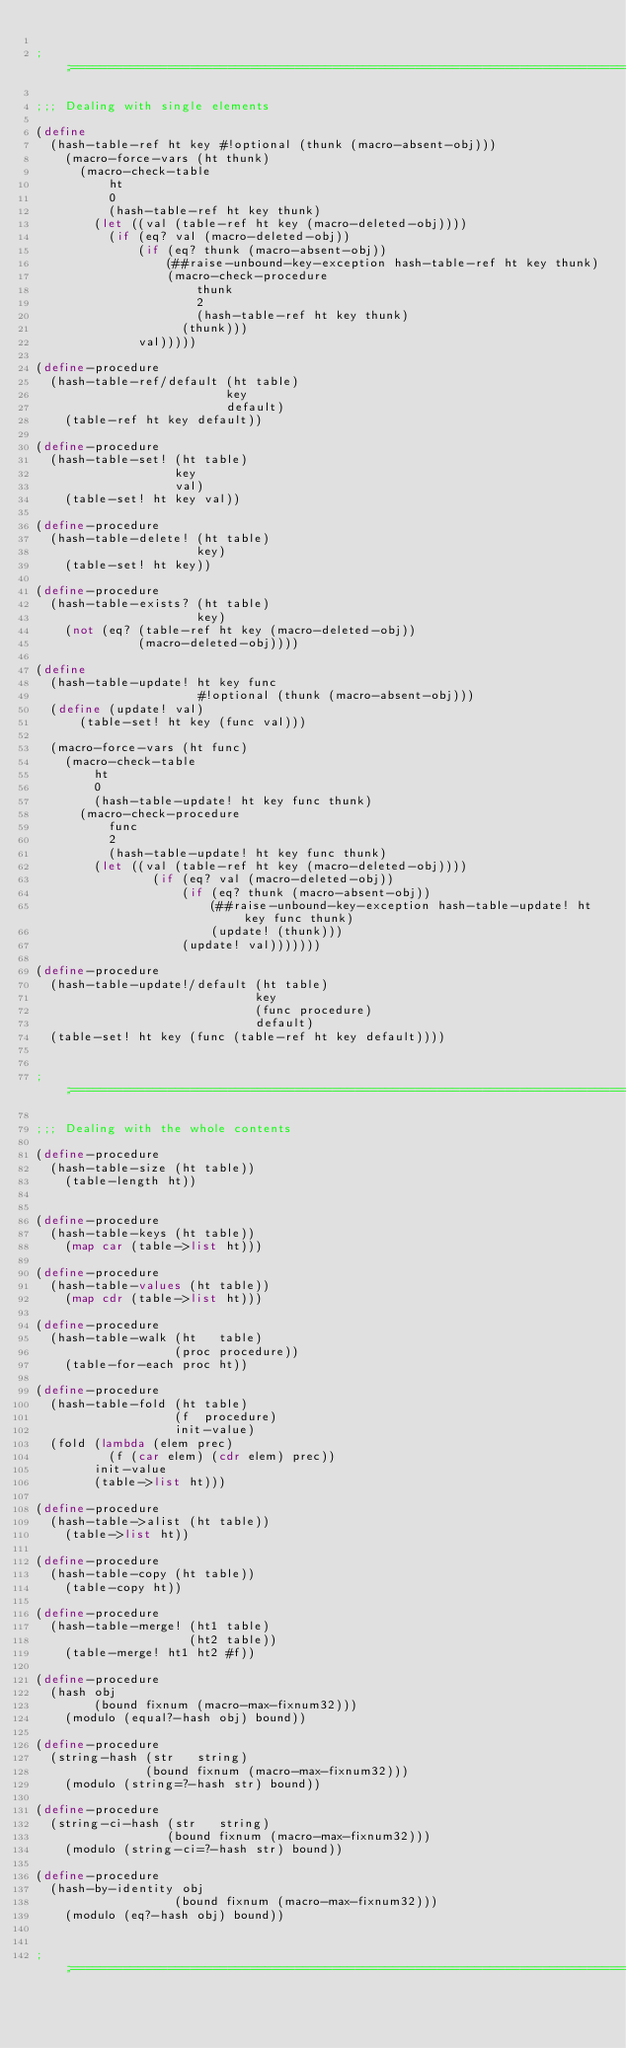<code> <loc_0><loc_0><loc_500><loc_500><_Scheme_>
;;;============================================================================

;;; Dealing with single elements

(define
  (hash-table-ref ht key #!optional (thunk (macro-absent-obj)))
    (macro-force-vars (ht thunk)
      (macro-check-table 
          ht
          0
          (hash-table-ref ht key thunk)
        (let ((val (table-ref ht key (macro-deleted-obj))))
          (if (eq? val (macro-deleted-obj))
              (if (eq? thunk (macro-absent-obj))
                  (##raise-unbound-key-exception hash-table-ref ht key thunk)
                  (macro-check-procedure
                      thunk
                      2
                      (hash-table-ref ht key thunk)
                    (thunk)))
              val)))))

(define-procedure
  (hash-table-ref/default (ht table) 
                          key 
                          default)
    (table-ref ht key default))

(define-procedure
  (hash-table-set! (ht table) 
                   key 
                   val)
    (table-set! ht key val))

(define-procedure
  (hash-table-delete! (ht table) 
                      key)
    (table-set! ht key))

(define-procedure
  (hash-table-exists? (ht table) 
                      key)
    (not (eq? (table-ref ht key (macro-deleted-obj))
              (macro-deleted-obj))))

(define
  (hash-table-update! ht key func
                      #!optional (thunk (macro-absent-obj)))
  (define (update! val)
      (table-set! ht key (func val)))

  (macro-force-vars (ht func)
    (macro-check-table 
        ht
        0
        (hash-table-update! ht key func thunk)
      (macro-check-procedure
          func
          2
          (hash-table-update! ht key func thunk)
        (let ((val (table-ref ht key (macro-deleted-obj))))
                (if (eq? val (macro-deleted-obj))
                    (if (eq? thunk (macro-absent-obj))
                        (##raise-unbound-key-exception hash-table-update! ht key func thunk)
                        (update! (thunk)))
                    (update! val)))))))

(define-procedure
  (hash-table-update!/default (ht table)
                              key 
                              (func procedure)
                              default)
  (table-set! ht key (func (table-ref ht key default))))


;;;============================================================================

;;; Dealing with the whole contents

(define-procedure
  (hash-table-size (ht table))
    (table-length ht))


(define-procedure
  (hash-table-keys (ht table))
    (map car (table->list ht)))

(define-procedure
  (hash-table-values (ht table))
    (map cdr (table->list ht)))

(define-procedure
  (hash-table-walk (ht   table) 
                   (proc procedure))
    (table-for-each proc ht))

(define-procedure
  (hash-table-fold (ht table)
                   (f  procedure)
                   init-value)
  (fold (lambda (elem prec)
          (f (car elem) (cdr elem) prec))
        init-value
        (table->list ht)))

(define-procedure
  (hash-table->alist (ht table))
    (table->list ht))

(define-procedure
  (hash-table-copy (ht table))
    (table-copy ht))

(define-procedure
  (hash-table-merge! (ht1 table)
                     (ht2 table))
    (table-merge! ht1 ht2 #f))

(define-procedure
  (hash obj
        (bound fixnum (macro-max-fixnum32)))
    (modulo (equal?-hash obj) bound))

(define-procedure
  (string-hash (str   string) 
               (bound fixnum (macro-max-fixnum32)))
    (modulo (string=?-hash str) bound))

(define-procedure
  (string-ci-hash (str   string) 
                  (bound fixnum (macro-max-fixnum32)))
    (modulo (string-ci=?-hash str) bound))

(define-procedure 
  (hash-by-identity obj 
                   (bound fixnum (macro-max-fixnum32)))
    (modulo (eq?-hash obj) bound))


;;;============================================================================
</code> 